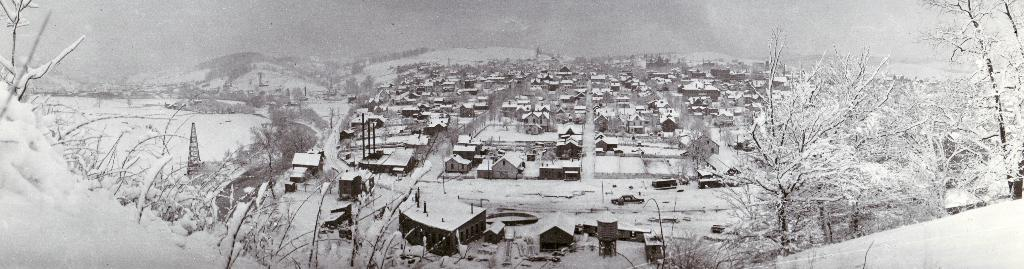What is located in the foreground of the image? There are trees in front in the image. What is the weather condition in the image? There is snow visible in the image, indicating a cold or wintery condition. What can be seen in the distance in the image? There are buildings in the background of the image. What else is present in the background of the image? There are more trees in the background of the image. How is the image presented in terms of color? The image is black and white. What time of day is it in the image? The image is black and white, so it is not possible to determine the time of day from the image. How many sons are visible in the image? There are no people, including sons, present in the image. 